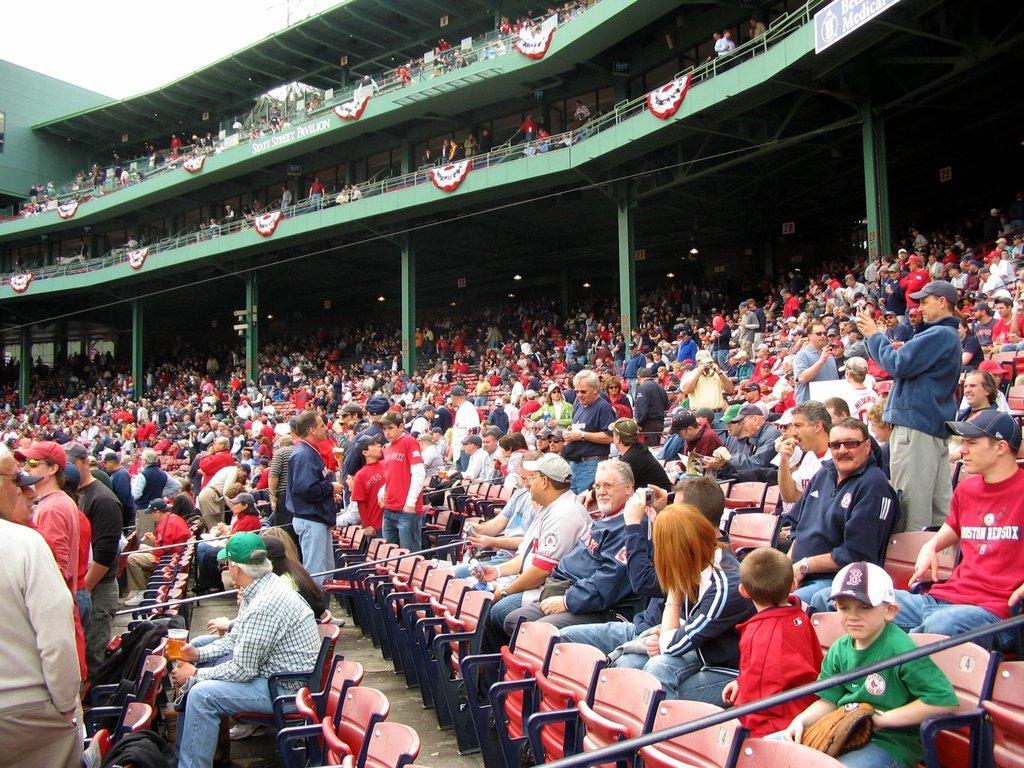How would you summarize this image in a sentence or two? In this image we can see audience sitting on the chairs and few other persons among them are standing. we can see railings, pillars, hoardings, sky and objects. 